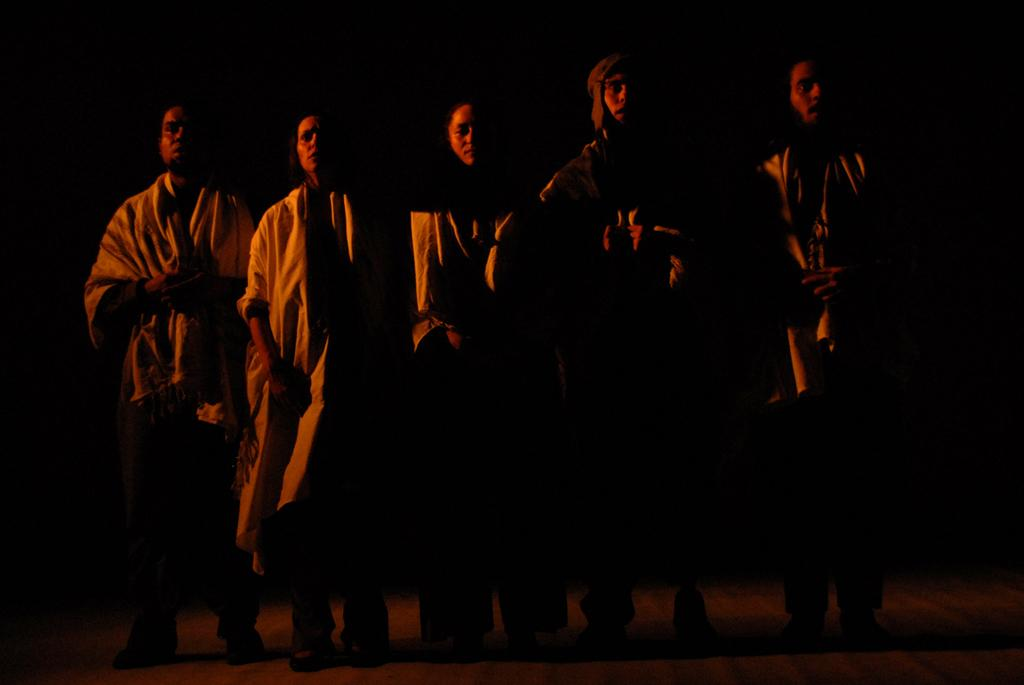How many people are present in the image? There are five persons in the image. What is the position of the persons in the image? The persons are standing on the floor. What is the color or lighting condition of the background in the image? The background of the image is dark. What is the taste of the spoon in the image? There is no spoon present in the image, so it is not possible to determine its taste. 